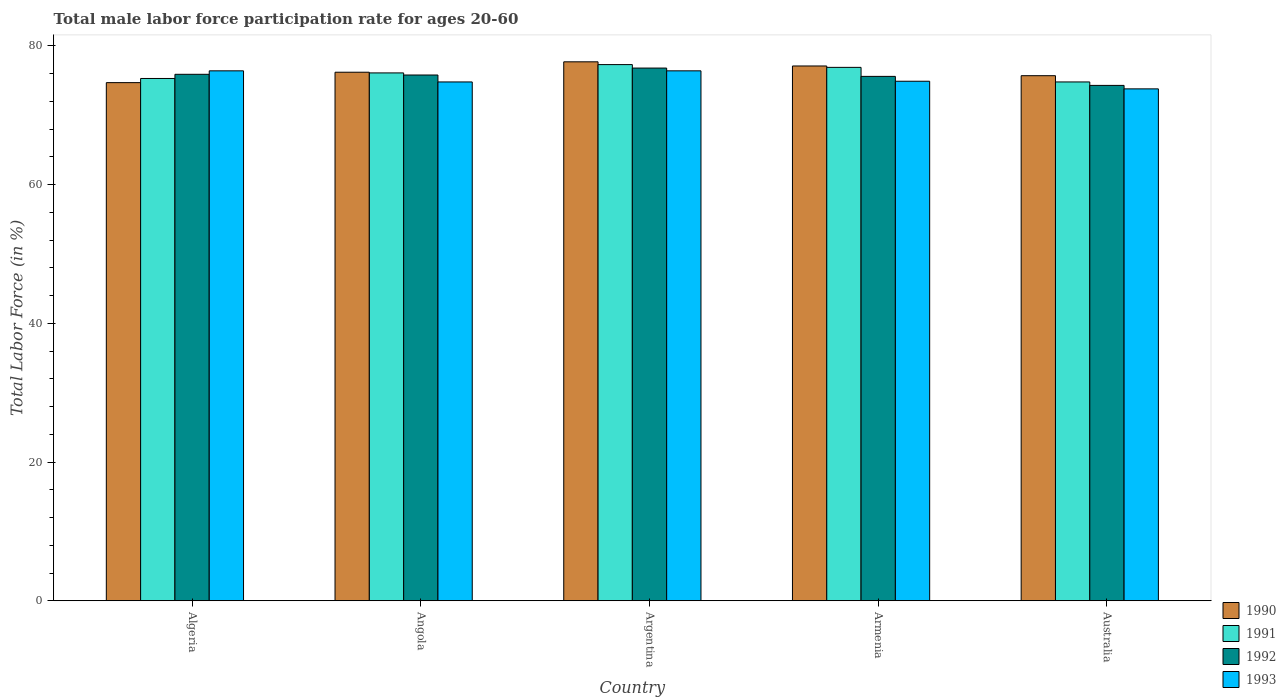Are the number of bars per tick equal to the number of legend labels?
Provide a short and direct response. Yes. Are the number of bars on each tick of the X-axis equal?
Provide a short and direct response. Yes. What is the male labor force participation rate in 1992 in Armenia?
Offer a very short reply. 75.6. Across all countries, what is the maximum male labor force participation rate in 1991?
Your answer should be compact. 77.3. Across all countries, what is the minimum male labor force participation rate in 1990?
Offer a terse response. 74.7. What is the total male labor force participation rate in 1991 in the graph?
Provide a succinct answer. 380.4. What is the difference between the male labor force participation rate in 1992 in Armenia and the male labor force participation rate in 1991 in Algeria?
Your answer should be very brief. 0.3. What is the average male labor force participation rate in 1991 per country?
Make the answer very short. 76.08. What is the difference between the male labor force participation rate of/in 1991 and male labor force participation rate of/in 1993 in Angola?
Ensure brevity in your answer.  1.3. In how many countries, is the male labor force participation rate in 1990 greater than 32 %?
Keep it short and to the point. 5. What is the ratio of the male labor force participation rate in 1993 in Algeria to that in Australia?
Keep it short and to the point. 1.04. Is the male labor force participation rate in 1992 in Argentina less than that in Armenia?
Make the answer very short. No. What is the difference between the highest and the second highest male labor force participation rate in 1992?
Offer a terse response. -0.1. Is it the case that in every country, the sum of the male labor force participation rate in 1990 and male labor force participation rate in 1993 is greater than the sum of male labor force participation rate in 1991 and male labor force participation rate in 1992?
Ensure brevity in your answer.  Yes. Does the graph contain any zero values?
Ensure brevity in your answer.  No. How many legend labels are there?
Offer a terse response. 4. How are the legend labels stacked?
Give a very brief answer. Vertical. What is the title of the graph?
Make the answer very short. Total male labor force participation rate for ages 20-60. What is the Total Labor Force (in %) of 1990 in Algeria?
Ensure brevity in your answer.  74.7. What is the Total Labor Force (in %) of 1991 in Algeria?
Offer a terse response. 75.3. What is the Total Labor Force (in %) of 1992 in Algeria?
Offer a very short reply. 75.9. What is the Total Labor Force (in %) in 1993 in Algeria?
Offer a very short reply. 76.4. What is the Total Labor Force (in %) of 1990 in Angola?
Keep it short and to the point. 76.2. What is the Total Labor Force (in %) of 1991 in Angola?
Your response must be concise. 76.1. What is the Total Labor Force (in %) of 1992 in Angola?
Ensure brevity in your answer.  75.8. What is the Total Labor Force (in %) in 1993 in Angola?
Provide a short and direct response. 74.8. What is the Total Labor Force (in %) of 1990 in Argentina?
Offer a very short reply. 77.7. What is the Total Labor Force (in %) of 1991 in Argentina?
Give a very brief answer. 77.3. What is the Total Labor Force (in %) in 1992 in Argentina?
Your answer should be very brief. 76.8. What is the Total Labor Force (in %) in 1993 in Argentina?
Provide a succinct answer. 76.4. What is the Total Labor Force (in %) in 1990 in Armenia?
Provide a short and direct response. 77.1. What is the Total Labor Force (in %) of 1991 in Armenia?
Provide a short and direct response. 76.9. What is the Total Labor Force (in %) of 1992 in Armenia?
Offer a very short reply. 75.6. What is the Total Labor Force (in %) of 1993 in Armenia?
Keep it short and to the point. 74.9. What is the Total Labor Force (in %) in 1990 in Australia?
Provide a succinct answer. 75.7. What is the Total Labor Force (in %) of 1991 in Australia?
Your answer should be compact. 74.8. What is the Total Labor Force (in %) of 1992 in Australia?
Your response must be concise. 74.3. What is the Total Labor Force (in %) in 1993 in Australia?
Keep it short and to the point. 73.8. Across all countries, what is the maximum Total Labor Force (in %) of 1990?
Your answer should be compact. 77.7. Across all countries, what is the maximum Total Labor Force (in %) in 1991?
Keep it short and to the point. 77.3. Across all countries, what is the maximum Total Labor Force (in %) of 1992?
Offer a terse response. 76.8. Across all countries, what is the maximum Total Labor Force (in %) in 1993?
Provide a short and direct response. 76.4. Across all countries, what is the minimum Total Labor Force (in %) of 1990?
Your answer should be compact. 74.7. Across all countries, what is the minimum Total Labor Force (in %) of 1991?
Ensure brevity in your answer.  74.8. Across all countries, what is the minimum Total Labor Force (in %) of 1992?
Offer a terse response. 74.3. Across all countries, what is the minimum Total Labor Force (in %) of 1993?
Your answer should be compact. 73.8. What is the total Total Labor Force (in %) of 1990 in the graph?
Your answer should be compact. 381.4. What is the total Total Labor Force (in %) of 1991 in the graph?
Provide a short and direct response. 380.4. What is the total Total Labor Force (in %) in 1992 in the graph?
Provide a short and direct response. 378.4. What is the total Total Labor Force (in %) in 1993 in the graph?
Ensure brevity in your answer.  376.3. What is the difference between the Total Labor Force (in %) of 1991 in Algeria and that in Angola?
Provide a short and direct response. -0.8. What is the difference between the Total Labor Force (in %) of 1993 in Algeria and that in Angola?
Your response must be concise. 1.6. What is the difference between the Total Labor Force (in %) in 1992 in Algeria and that in Argentina?
Ensure brevity in your answer.  -0.9. What is the difference between the Total Labor Force (in %) of 1993 in Algeria and that in Argentina?
Your response must be concise. 0. What is the difference between the Total Labor Force (in %) of 1990 in Algeria and that in Armenia?
Your response must be concise. -2.4. What is the difference between the Total Labor Force (in %) of 1992 in Algeria and that in Armenia?
Your answer should be very brief. 0.3. What is the difference between the Total Labor Force (in %) in 1993 in Algeria and that in Armenia?
Offer a terse response. 1.5. What is the difference between the Total Labor Force (in %) of 1990 in Algeria and that in Australia?
Keep it short and to the point. -1. What is the difference between the Total Labor Force (in %) of 1992 in Algeria and that in Australia?
Offer a very short reply. 1.6. What is the difference between the Total Labor Force (in %) of 1991 in Angola and that in Argentina?
Keep it short and to the point. -1.2. What is the difference between the Total Labor Force (in %) in 1992 in Angola and that in Argentina?
Offer a terse response. -1. What is the difference between the Total Labor Force (in %) in 1993 in Angola and that in Argentina?
Keep it short and to the point. -1.6. What is the difference between the Total Labor Force (in %) in 1991 in Angola and that in Armenia?
Offer a terse response. -0.8. What is the difference between the Total Labor Force (in %) in 1993 in Angola and that in Armenia?
Make the answer very short. -0.1. What is the difference between the Total Labor Force (in %) of 1990 in Angola and that in Australia?
Keep it short and to the point. 0.5. What is the difference between the Total Labor Force (in %) of 1993 in Argentina and that in Armenia?
Offer a very short reply. 1.5. What is the difference between the Total Labor Force (in %) in 1990 in Armenia and that in Australia?
Your answer should be compact. 1.4. What is the difference between the Total Labor Force (in %) of 1991 in Armenia and that in Australia?
Provide a succinct answer. 2.1. What is the difference between the Total Labor Force (in %) of 1992 in Armenia and that in Australia?
Offer a very short reply. 1.3. What is the difference between the Total Labor Force (in %) in 1993 in Armenia and that in Australia?
Offer a very short reply. 1.1. What is the difference between the Total Labor Force (in %) of 1990 in Algeria and the Total Labor Force (in %) of 1992 in Angola?
Ensure brevity in your answer.  -1.1. What is the difference between the Total Labor Force (in %) of 1990 in Algeria and the Total Labor Force (in %) of 1993 in Angola?
Your response must be concise. -0.1. What is the difference between the Total Labor Force (in %) of 1991 in Algeria and the Total Labor Force (in %) of 1993 in Angola?
Keep it short and to the point. 0.5. What is the difference between the Total Labor Force (in %) of 1992 in Algeria and the Total Labor Force (in %) of 1993 in Angola?
Offer a terse response. 1.1. What is the difference between the Total Labor Force (in %) of 1990 in Algeria and the Total Labor Force (in %) of 1991 in Argentina?
Provide a succinct answer. -2.6. What is the difference between the Total Labor Force (in %) of 1990 in Algeria and the Total Labor Force (in %) of 1992 in Argentina?
Make the answer very short. -2.1. What is the difference between the Total Labor Force (in %) in 1991 in Algeria and the Total Labor Force (in %) in 1992 in Argentina?
Your response must be concise. -1.5. What is the difference between the Total Labor Force (in %) in 1992 in Algeria and the Total Labor Force (in %) in 1993 in Argentina?
Your response must be concise. -0.5. What is the difference between the Total Labor Force (in %) in 1990 in Algeria and the Total Labor Force (in %) in 1992 in Armenia?
Your response must be concise. -0.9. What is the difference between the Total Labor Force (in %) of 1991 in Algeria and the Total Labor Force (in %) of 1993 in Armenia?
Offer a very short reply. 0.4. What is the difference between the Total Labor Force (in %) in 1990 in Algeria and the Total Labor Force (in %) in 1991 in Australia?
Your answer should be very brief. -0.1. What is the difference between the Total Labor Force (in %) of 1990 in Algeria and the Total Labor Force (in %) of 1992 in Australia?
Give a very brief answer. 0.4. What is the difference between the Total Labor Force (in %) of 1992 in Algeria and the Total Labor Force (in %) of 1993 in Australia?
Keep it short and to the point. 2.1. What is the difference between the Total Labor Force (in %) of 1990 in Angola and the Total Labor Force (in %) of 1991 in Argentina?
Your response must be concise. -1.1. What is the difference between the Total Labor Force (in %) of 1990 in Angola and the Total Labor Force (in %) of 1993 in Argentina?
Keep it short and to the point. -0.2. What is the difference between the Total Labor Force (in %) of 1991 in Angola and the Total Labor Force (in %) of 1993 in Argentina?
Give a very brief answer. -0.3. What is the difference between the Total Labor Force (in %) in 1990 in Angola and the Total Labor Force (in %) in 1992 in Armenia?
Ensure brevity in your answer.  0.6. What is the difference between the Total Labor Force (in %) of 1991 in Angola and the Total Labor Force (in %) of 1992 in Armenia?
Your response must be concise. 0.5. What is the difference between the Total Labor Force (in %) in 1990 in Angola and the Total Labor Force (in %) in 1991 in Australia?
Provide a succinct answer. 1.4. What is the difference between the Total Labor Force (in %) of 1990 in Argentina and the Total Labor Force (in %) of 1991 in Armenia?
Provide a succinct answer. 0.8. What is the difference between the Total Labor Force (in %) of 1990 in Argentina and the Total Labor Force (in %) of 1992 in Armenia?
Your answer should be compact. 2.1. What is the difference between the Total Labor Force (in %) in 1990 in Argentina and the Total Labor Force (in %) in 1993 in Armenia?
Make the answer very short. 2.8. What is the difference between the Total Labor Force (in %) in 1991 in Argentina and the Total Labor Force (in %) in 1993 in Armenia?
Keep it short and to the point. 2.4. What is the difference between the Total Labor Force (in %) in 1992 in Argentina and the Total Labor Force (in %) in 1993 in Armenia?
Keep it short and to the point. 1.9. What is the difference between the Total Labor Force (in %) of 1990 in Argentina and the Total Labor Force (in %) of 1991 in Australia?
Your answer should be compact. 2.9. What is the difference between the Total Labor Force (in %) of 1992 in Argentina and the Total Labor Force (in %) of 1993 in Australia?
Your answer should be compact. 3. What is the difference between the Total Labor Force (in %) in 1990 in Armenia and the Total Labor Force (in %) in 1991 in Australia?
Offer a terse response. 2.3. What is the difference between the Total Labor Force (in %) of 1991 in Armenia and the Total Labor Force (in %) of 1992 in Australia?
Your answer should be very brief. 2.6. What is the average Total Labor Force (in %) in 1990 per country?
Provide a short and direct response. 76.28. What is the average Total Labor Force (in %) in 1991 per country?
Provide a succinct answer. 76.08. What is the average Total Labor Force (in %) of 1992 per country?
Keep it short and to the point. 75.68. What is the average Total Labor Force (in %) in 1993 per country?
Make the answer very short. 75.26. What is the difference between the Total Labor Force (in %) in 1990 and Total Labor Force (in %) in 1991 in Algeria?
Make the answer very short. -0.6. What is the difference between the Total Labor Force (in %) in 1991 and Total Labor Force (in %) in 1993 in Algeria?
Offer a terse response. -1.1. What is the difference between the Total Labor Force (in %) of 1990 and Total Labor Force (in %) of 1993 in Angola?
Offer a very short reply. 1.4. What is the difference between the Total Labor Force (in %) of 1991 and Total Labor Force (in %) of 1993 in Angola?
Provide a short and direct response. 1.3. What is the difference between the Total Labor Force (in %) in 1990 and Total Labor Force (in %) in 1993 in Argentina?
Keep it short and to the point. 1.3. What is the difference between the Total Labor Force (in %) of 1990 and Total Labor Force (in %) of 1991 in Armenia?
Give a very brief answer. 0.2. What is the difference between the Total Labor Force (in %) in 1990 and Total Labor Force (in %) in 1992 in Armenia?
Offer a very short reply. 1.5. What is the difference between the Total Labor Force (in %) of 1990 and Total Labor Force (in %) of 1993 in Armenia?
Offer a terse response. 2.2. What is the difference between the Total Labor Force (in %) in 1991 and Total Labor Force (in %) in 1993 in Armenia?
Provide a succinct answer. 2. What is the difference between the Total Labor Force (in %) of 1992 and Total Labor Force (in %) of 1993 in Armenia?
Your answer should be compact. 0.7. What is the difference between the Total Labor Force (in %) in 1990 and Total Labor Force (in %) in 1992 in Australia?
Provide a short and direct response. 1.4. What is the difference between the Total Labor Force (in %) in 1991 and Total Labor Force (in %) in 1993 in Australia?
Provide a succinct answer. 1. What is the ratio of the Total Labor Force (in %) in 1990 in Algeria to that in Angola?
Give a very brief answer. 0.98. What is the ratio of the Total Labor Force (in %) in 1992 in Algeria to that in Angola?
Offer a very short reply. 1. What is the ratio of the Total Labor Force (in %) of 1993 in Algeria to that in Angola?
Offer a terse response. 1.02. What is the ratio of the Total Labor Force (in %) in 1990 in Algeria to that in Argentina?
Make the answer very short. 0.96. What is the ratio of the Total Labor Force (in %) in 1991 in Algeria to that in Argentina?
Your answer should be very brief. 0.97. What is the ratio of the Total Labor Force (in %) in 1992 in Algeria to that in Argentina?
Your response must be concise. 0.99. What is the ratio of the Total Labor Force (in %) of 1993 in Algeria to that in Argentina?
Offer a very short reply. 1. What is the ratio of the Total Labor Force (in %) in 1990 in Algeria to that in Armenia?
Ensure brevity in your answer.  0.97. What is the ratio of the Total Labor Force (in %) of 1991 in Algeria to that in Armenia?
Keep it short and to the point. 0.98. What is the ratio of the Total Labor Force (in %) of 1993 in Algeria to that in Armenia?
Give a very brief answer. 1.02. What is the ratio of the Total Labor Force (in %) in 1992 in Algeria to that in Australia?
Provide a short and direct response. 1.02. What is the ratio of the Total Labor Force (in %) of 1993 in Algeria to that in Australia?
Provide a short and direct response. 1.04. What is the ratio of the Total Labor Force (in %) of 1990 in Angola to that in Argentina?
Your answer should be compact. 0.98. What is the ratio of the Total Labor Force (in %) of 1991 in Angola to that in Argentina?
Offer a terse response. 0.98. What is the ratio of the Total Labor Force (in %) of 1992 in Angola to that in Argentina?
Keep it short and to the point. 0.99. What is the ratio of the Total Labor Force (in %) of 1993 in Angola to that in Argentina?
Your answer should be very brief. 0.98. What is the ratio of the Total Labor Force (in %) in 1990 in Angola to that in Armenia?
Provide a succinct answer. 0.99. What is the ratio of the Total Labor Force (in %) in 1991 in Angola to that in Armenia?
Provide a short and direct response. 0.99. What is the ratio of the Total Labor Force (in %) in 1993 in Angola to that in Armenia?
Give a very brief answer. 1. What is the ratio of the Total Labor Force (in %) in 1990 in Angola to that in Australia?
Provide a succinct answer. 1.01. What is the ratio of the Total Labor Force (in %) of 1991 in Angola to that in Australia?
Provide a succinct answer. 1.02. What is the ratio of the Total Labor Force (in %) of 1992 in Angola to that in Australia?
Make the answer very short. 1.02. What is the ratio of the Total Labor Force (in %) in 1993 in Angola to that in Australia?
Your answer should be very brief. 1.01. What is the ratio of the Total Labor Force (in %) in 1991 in Argentina to that in Armenia?
Offer a terse response. 1.01. What is the ratio of the Total Labor Force (in %) of 1992 in Argentina to that in Armenia?
Offer a terse response. 1.02. What is the ratio of the Total Labor Force (in %) in 1993 in Argentina to that in Armenia?
Ensure brevity in your answer.  1.02. What is the ratio of the Total Labor Force (in %) in 1990 in Argentina to that in Australia?
Offer a very short reply. 1.03. What is the ratio of the Total Labor Force (in %) of 1991 in Argentina to that in Australia?
Give a very brief answer. 1.03. What is the ratio of the Total Labor Force (in %) in 1992 in Argentina to that in Australia?
Offer a terse response. 1.03. What is the ratio of the Total Labor Force (in %) in 1993 in Argentina to that in Australia?
Ensure brevity in your answer.  1.04. What is the ratio of the Total Labor Force (in %) in 1990 in Armenia to that in Australia?
Provide a short and direct response. 1.02. What is the ratio of the Total Labor Force (in %) in 1991 in Armenia to that in Australia?
Make the answer very short. 1.03. What is the ratio of the Total Labor Force (in %) in 1992 in Armenia to that in Australia?
Keep it short and to the point. 1.02. What is the ratio of the Total Labor Force (in %) of 1993 in Armenia to that in Australia?
Offer a very short reply. 1.01. What is the difference between the highest and the second highest Total Labor Force (in %) in 1991?
Your response must be concise. 0.4. What is the difference between the highest and the lowest Total Labor Force (in %) in 1991?
Your answer should be very brief. 2.5. 